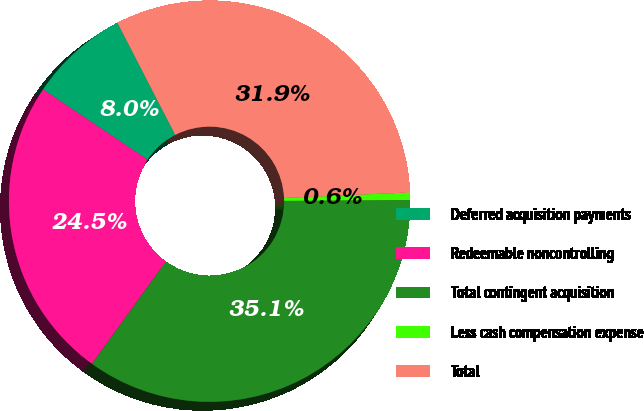Convert chart to OTSL. <chart><loc_0><loc_0><loc_500><loc_500><pie_chart><fcel>Deferred acquisition payments<fcel>Redeemable noncontrolling<fcel>Total contingent acquisition<fcel>Less cash compensation expense<fcel>Total<nl><fcel>8.01%<fcel>24.46%<fcel>35.06%<fcel>0.6%<fcel>31.87%<nl></chart> 